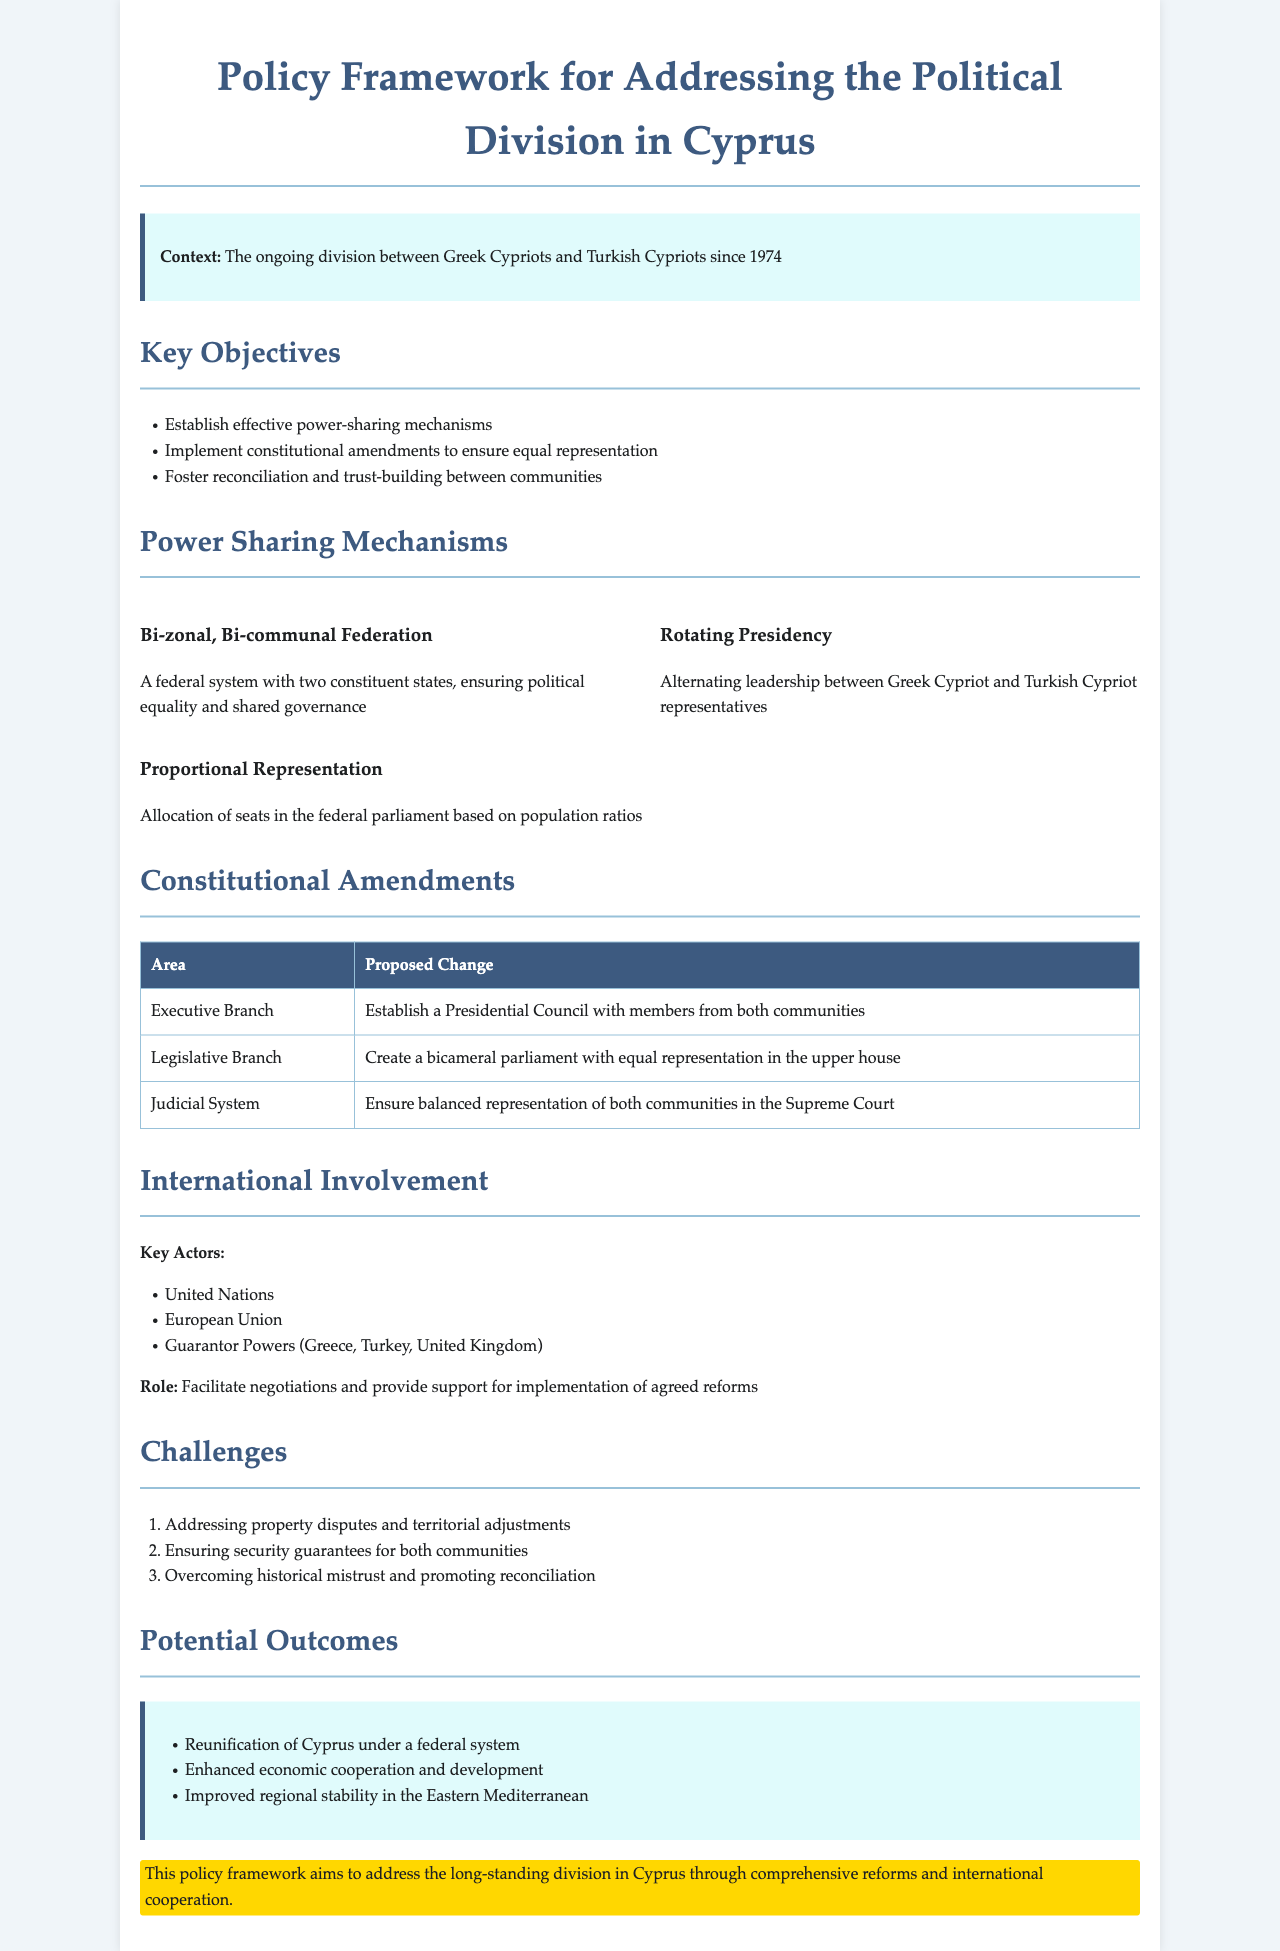What are the key objectives? The key objectives include establishing effective power-sharing mechanisms, implementing constitutional amendments to ensure equal representation, and fostering reconciliation and trust-building between communities.
Answer: Establish effective power-sharing mechanisms, implement constitutional amendments to ensure equal representation, foster reconciliation and trust-building between communities What does bi-zonal, bi-communal federation entail? Bi-zonal, bi-communal federation is a federal system with two constituent states ensuring political equality and shared governance.
Answer: A federal system with two constituent states, ensuring political equality and shared governance What is proposed for the executive branch? The proposed change for the executive branch is to establish a Presidential Council with members from both communities.
Answer: Establish a Presidential Council with members from both communities How is the legislative branch structured? The legislative branch is proposed to be a bicameral parliament with equal representation in the upper house.
Answer: Create a bicameral parliament with equal representation in the upper house What are the key actors involved in international involvement? Key actors include the United Nations, European Union, and Guarantor Powers (Greece, Turkey, United Kingdom).
Answer: United Nations, European Union, Guarantor Powers (Greece, Turkey, United Kingdom) What is one of the challenges mentioned? One of the challenges is addressing property disputes and territorial adjustments.
Answer: Addressing property disputes and territorial adjustments What is a potential outcome of this policy framework? A potential outcome is the reunification of Cyprus under a federal system.
Answer: Reunification of Cyprus under a federal system What is the role of international actors? The role of international actors is to facilitate negotiations and provide support for implementation of agreed reforms.
Answer: Facilitate negotiations and provide support for implementation of agreed reforms 